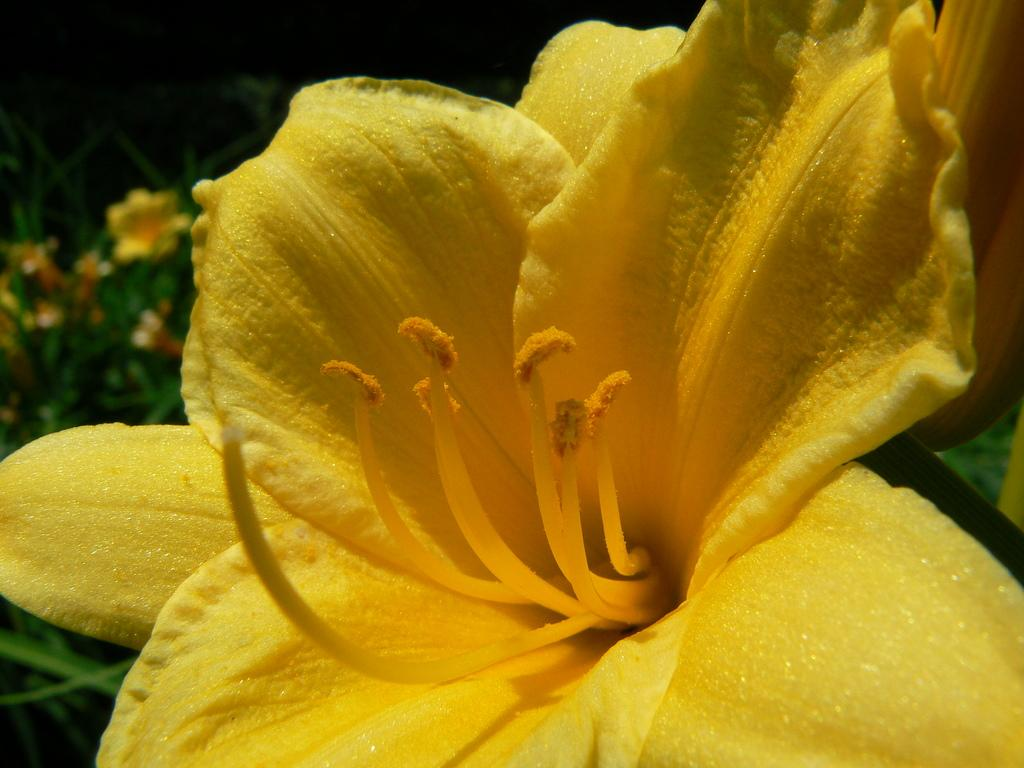What color is the flower in the picture? The flower in the picture is yellow. Are there any other flowers or plants with the same color in the picture? Yes, there are plants with yellow flowers in the background of the picture. Where can we find a map of the zoo in the picture? There is no map or zoo present in the picture; it features a yellow flower and plants with yellow flowers in the background. 